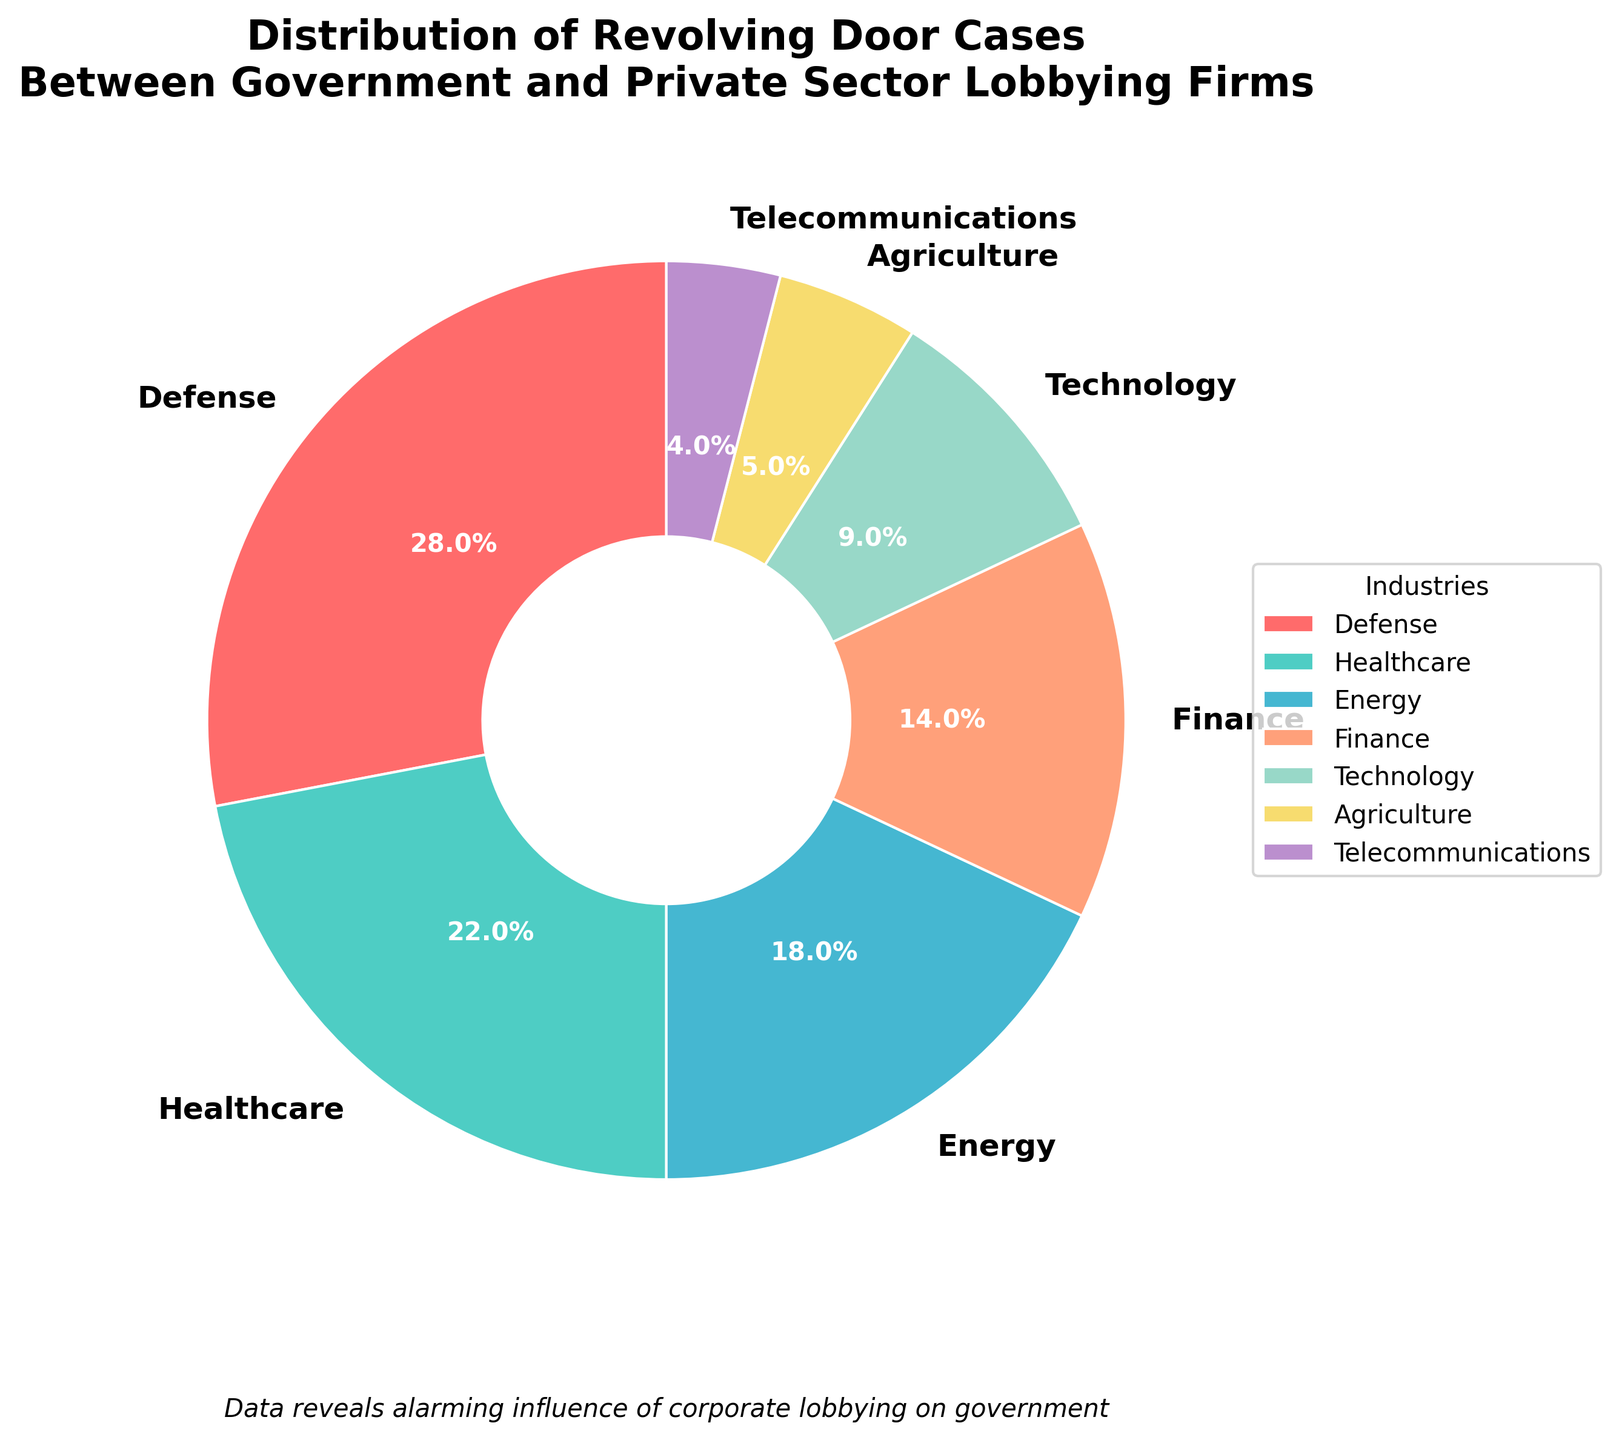What percentage of revolving door cases does the healthcare industry represent? The pie chart directly labels each industry's percentage. The healthcare industry is labeled as 22%.
Answer: 22% Which industry has the highest percentage of revolving door cases? By observing the size of the pie slices and their labels, the defense industry has the largest slice at 28%.
Answer: Defense How do the combined percentages of the finance and technology industries compare to the healthcare industry? The chart shows finance at 14% and technology at 9%. Combined, they total 14% + 9% = 23%, which is 1% higher than the healthcare industry's 22%.
Answer: 23%, 1% higher If you sum the percentages of the two smallest industries, would it surpass the percentage of the telecommunications industry? The smallest industries are agriculture at 5% and telecommunications at 4%. Summing these, 5% + 4% = 9%, which equals the percentage for technology. Thus, it does not surpass the telecommunications percentage alone.
Answer: 9%, equal What is the collective percentage of the technology and agriculture industries? The chart indicates technology at 9% and agriculture at 5%. Adding these, 9% + 5% = 14%.
Answer: 14% Which industry represents exactly half the percentage of the leading industry? The leading industry is defense at 28%. Half of this is 28% / 2 = 14%, which matches the percentage for the finance industry.
Answer: Finance Is the percentage of revolving door cases in the energy industry more or less than double that of the telecommunications industry? Energy is at 18% and telecommunications at 4%. Doubling telecommunications, 4% * 2 = 8%, which is less than energy's 18%.
Answer: More What visual feature indicates the industry with the smallest percentage? The industry with the smallest percentage has the smallest pie slice, which corresponds to telecommunications at 4%.
Answer: Smallest pie slice Compare the total percentage of the defense and healthcare industries to the total of finance, technology, and agriculture. Defense is at 28% and healthcare at 22%, totaling 28% + 22% = 50%. Finance is 14%, technology is 9%, and agriculture is 5%, totaling 14% + 9% + 5% = 28%.
Answer: 50% vs 28% What is the difference in percentage between the energy industry and the agriculture industry? The energy industry is at 18% and agriculture is at 5%. The difference is 18% - 5% = 13%.
Answer: 13% 